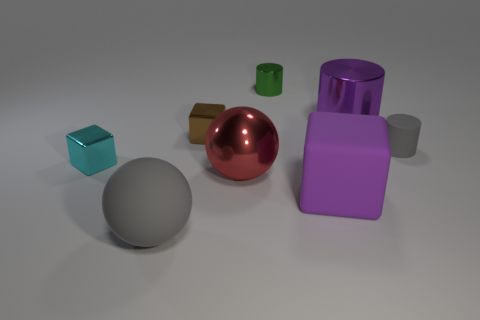Are there any purple things of the same size as the green shiny cylinder?
Your response must be concise. No. What is the shape of the large red metal object?
Provide a succinct answer. Sphere. Are there more large red balls that are in front of the big block than large red objects that are right of the tiny brown shiny thing?
Offer a terse response. No. Is the color of the shiny thing that is right of the small green metallic object the same as the rubber object that is behind the tiny cyan shiny thing?
Your answer should be compact. No. What shape is the green metal thing that is the same size as the brown object?
Make the answer very short. Cylinder. Is there a tiny blue matte thing that has the same shape as the tiny green metal object?
Offer a terse response. No. Is the material of the big purple thing that is in front of the red metal sphere the same as the small cylinder that is in front of the green object?
Offer a very short reply. Yes. What shape is the tiny matte thing that is the same color as the large rubber sphere?
Your answer should be very brief. Cylinder. What number of gray things are the same material as the gray ball?
Offer a terse response. 1. The tiny metallic cylinder has what color?
Give a very brief answer. Green. 